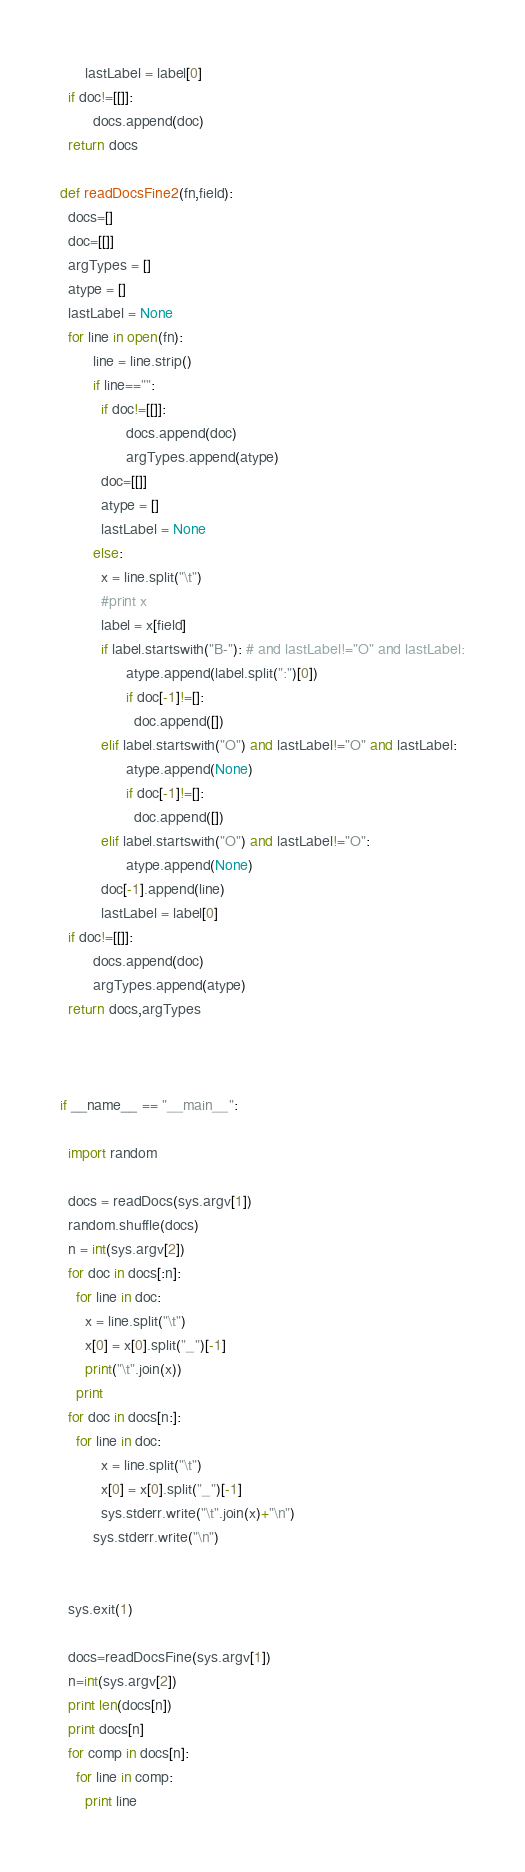<code> <loc_0><loc_0><loc_500><loc_500><_Python_>	  lastLabel = label[0]
  if doc!=[[]]:
        docs.append(doc)
  return docs

def readDocsFine2(fn,field):
  docs=[]
  doc=[[]]
  argTypes = []
  atype = []
  lastLabel = None
  for line in open(fn):
        line = line.strip()
        if line=="":
          if doc!=[[]]:
                docs.append(doc)
                argTypes.append(atype)
          doc=[[]]
          atype = []
          lastLabel = None
        else:
          x = line.split("\t")
          #print x
          label = x[field]
          if label.startswith("B-"): # and lastLabel!="O" and lastLabel:
                atype.append(label.split(":")[0])
                if doc[-1]!=[]:
                  doc.append([])
          elif label.startswith("O") and lastLabel!="O" and lastLabel:
                atype.append(None)
                if doc[-1]!=[]:
                  doc.append([])
          elif label.startswith("O") and lastLabel!="O":
                atype.append(None)
          doc[-1].append(line)
          lastLabel = label[0]
  if doc!=[[]]:
        docs.append(doc)
        argTypes.append(atype)
  return docs,argTypes



if __name__ == "__main__":

  import random

  docs = readDocs(sys.argv[1])
  random.shuffle(docs)
  n = int(sys.argv[2])
  for doc in docs[:n]:
	for line in doc:
	  x = line.split("\t")
	  x[0] = x[0].split("_")[-1]
	  print("\t".join(x))
	print
  for doc in docs[n:]:
	for line in doc:
          x = line.split("\t")
          x[0] = x[0].split("_")[-1]
          sys.stderr.write("\t".join(x)+"\n")
        sys.stderr.write("\n")


  sys.exit(1)

  docs=readDocsFine(sys.argv[1])
  n=int(sys.argv[2])
  print len(docs[n])
  print docs[n]
  for comp in docs[n]:
	for line in comp:
	  print line
</code> 